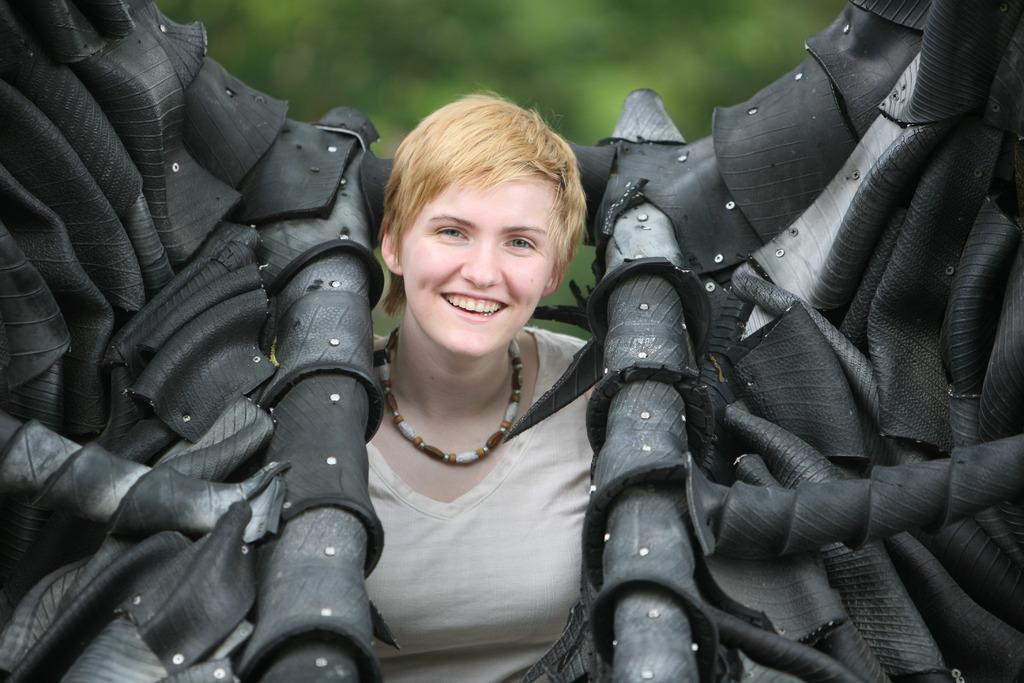Describe this image in one or two sentences. In this image I can see a person smiling and wearing white top. On the both-sides I can see a black color objects. Background is in green color. 